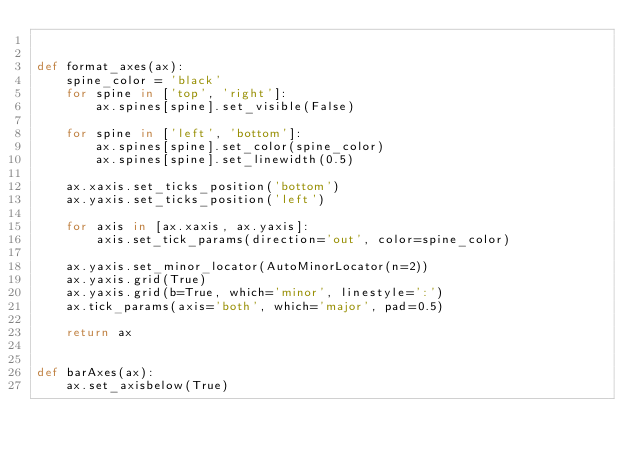Convert code to text. <code><loc_0><loc_0><loc_500><loc_500><_Python_>

def format_axes(ax):
    spine_color = 'black'
    for spine in ['top', 'right']:
        ax.spines[spine].set_visible(False)

    for spine in ['left', 'bottom']:
        ax.spines[spine].set_color(spine_color)
        ax.spines[spine].set_linewidth(0.5)

    ax.xaxis.set_ticks_position('bottom')
    ax.yaxis.set_ticks_position('left')

    for axis in [ax.xaxis, ax.yaxis]:
        axis.set_tick_params(direction='out', color=spine_color)

    ax.yaxis.set_minor_locator(AutoMinorLocator(n=2))
    ax.yaxis.grid(True)
    ax.yaxis.grid(b=True, which='minor', linestyle=':')
    ax.tick_params(axis='both', which='major', pad=0.5)

    return ax


def barAxes(ax):
    ax.set_axisbelow(True)

</code> 